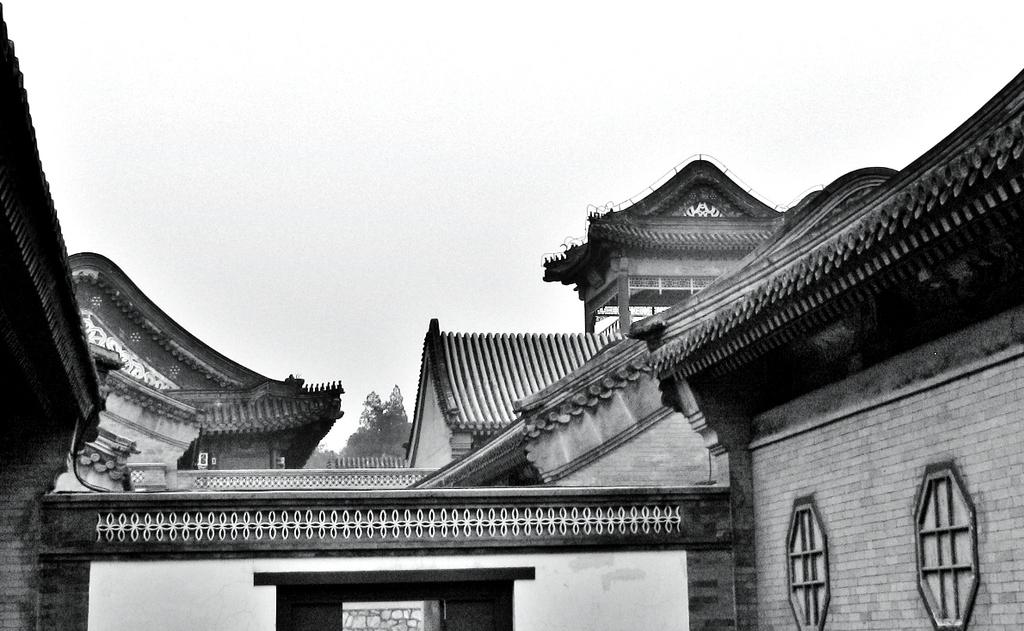What type of structures are present in the image? There are buildings in the image. What can be seen in the background of the image? The background of the image includes trees. What is visible in the sky in the image? The sky is visible in the background of the image. What is the color scheme of the image? The image is in black and white. How many thumbs can be seen attempting to draw a line in the image? There are no thumbs or attempts to draw a line visible in the image. 